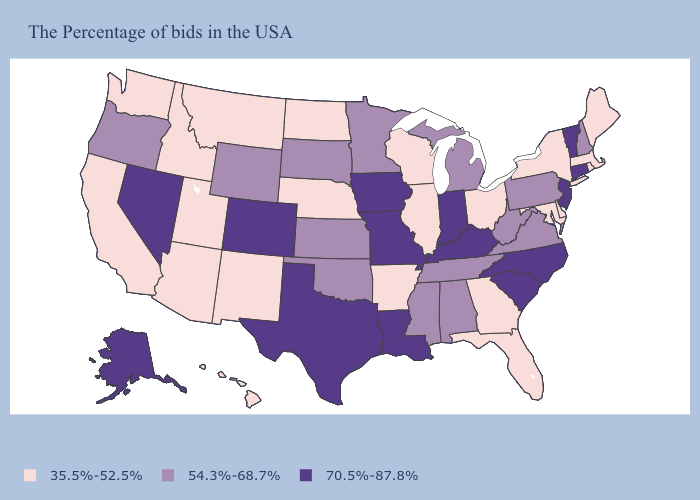Does Louisiana have the highest value in the USA?
Give a very brief answer. Yes. Does Kansas have the lowest value in the USA?
Short answer required. No. Among the states that border Kansas , which have the highest value?
Write a very short answer. Missouri, Colorado. Does the map have missing data?
Keep it brief. No. Does Rhode Island have the highest value in the Northeast?
Short answer required. No. Does the first symbol in the legend represent the smallest category?
Short answer required. Yes. Among the states that border Wisconsin , does Michigan have the lowest value?
Concise answer only. No. Among the states that border New York , which have the highest value?
Give a very brief answer. Vermont, Connecticut, New Jersey. What is the value of Wyoming?
Answer briefly. 54.3%-68.7%. Name the states that have a value in the range 54.3%-68.7%?
Be succinct. New Hampshire, Pennsylvania, Virginia, West Virginia, Michigan, Alabama, Tennessee, Mississippi, Minnesota, Kansas, Oklahoma, South Dakota, Wyoming, Oregon. Name the states that have a value in the range 54.3%-68.7%?
Short answer required. New Hampshire, Pennsylvania, Virginia, West Virginia, Michigan, Alabama, Tennessee, Mississippi, Minnesota, Kansas, Oklahoma, South Dakota, Wyoming, Oregon. What is the value of Delaware?
Give a very brief answer. 35.5%-52.5%. Name the states that have a value in the range 54.3%-68.7%?
Keep it brief. New Hampshire, Pennsylvania, Virginia, West Virginia, Michigan, Alabama, Tennessee, Mississippi, Minnesota, Kansas, Oklahoma, South Dakota, Wyoming, Oregon. Name the states that have a value in the range 70.5%-87.8%?
Give a very brief answer. Vermont, Connecticut, New Jersey, North Carolina, South Carolina, Kentucky, Indiana, Louisiana, Missouri, Iowa, Texas, Colorado, Nevada, Alaska. 